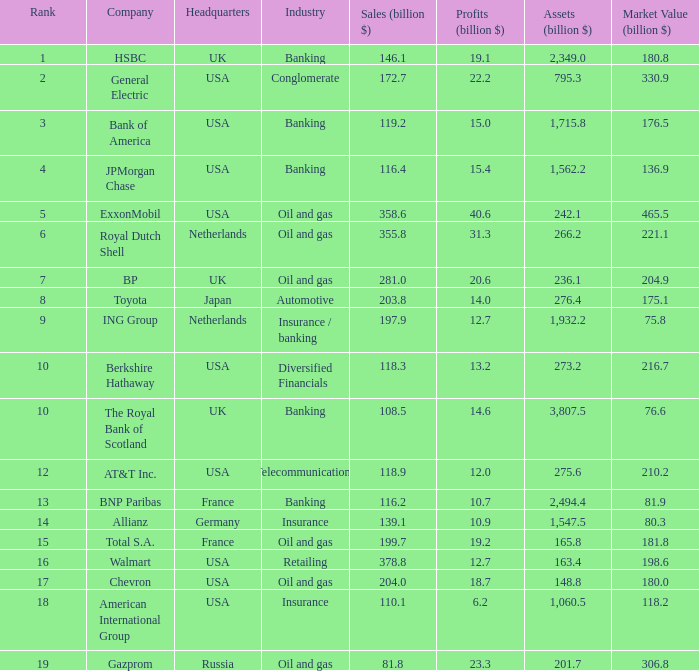For companies having a market value of 204.9 billion, what is their profit in billions? 20.6. Would you mind parsing the complete table? {'header': ['Rank', 'Company', 'Headquarters', 'Industry', 'Sales (billion $)', 'Profits (billion $)', 'Assets (billion $)', 'Market Value (billion $)'], 'rows': [['1', 'HSBC', 'UK', 'Banking', '146.1', '19.1', '2,349.0', '180.8'], ['2', 'General Electric', 'USA', 'Conglomerate', '172.7', '22.2', '795.3', '330.9'], ['3', 'Bank of America', 'USA', 'Banking', '119.2', '15.0', '1,715.8', '176.5'], ['4', 'JPMorgan Chase', 'USA', 'Banking', '116.4', '15.4', '1,562.2', '136.9'], ['5', 'ExxonMobil', 'USA', 'Oil and gas', '358.6', '40.6', '242.1', '465.5'], ['6', 'Royal Dutch Shell', 'Netherlands', 'Oil and gas', '355.8', '31.3', '266.2', '221.1'], ['7', 'BP', 'UK', 'Oil and gas', '281.0', '20.6', '236.1', '204.9'], ['8', 'Toyota', 'Japan', 'Automotive', '203.8', '14.0', '276.4', '175.1'], ['9', 'ING Group', 'Netherlands', 'Insurance / banking', '197.9', '12.7', '1,932.2', '75.8'], ['10', 'Berkshire Hathaway', 'USA', 'Diversified Financials', '118.3', '13.2', '273.2', '216.7'], ['10', 'The Royal Bank of Scotland', 'UK', 'Banking', '108.5', '14.6', '3,807.5', '76.6'], ['12', 'AT&T Inc.', 'USA', 'Telecommunications', '118.9', '12.0', '275.6', '210.2'], ['13', 'BNP Paribas', 'France', 'Banking', '116.2', '10.7', '2,494.4', '81.9'], ['14', 'Allianz', 'Germany', 'Insurance', '139.1', '10.9', '1,547.5', '80.3'], ['15', 'Total S.A.', 'France', 'Oil and gas', '199.7', '19.2', '165.8', '181.8'], ['16', 'Walmart', 'USA', 'Retailing', '378.8', '12.7', '163.4', '198.6'], ['17', 'Chevron', 'USA', 'Oil and gas', '204.0', '18.7', '148.8', '180.0'], ['18', 'American International Group', 'USA', 'Insurance', '110.1', '6.2', '1,060.5', '118.2'], ['19', 'Gazprom', 'Russia', 'Oil and gas', '81.8', '23.3', '201.7', '306.8']]} 